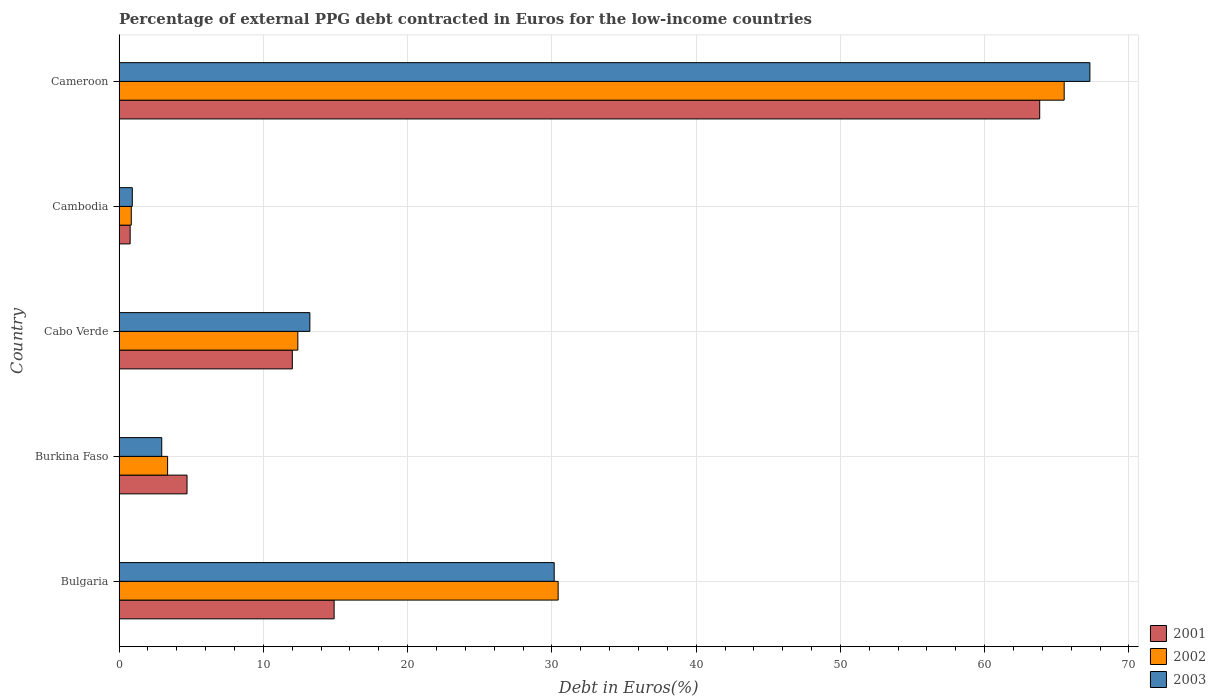Are the number of bars per tick equal to the number of legend labels?
Your answer should be compact. Yes. Are the number of bars on each tick of the Y-axis equal?
Your answer should be compact. Yes. How many bars are there on the 3rd tick from the top?
Make the answer very short. 3. How many bars are there on the 2nd tick from the bottom?
Provide a succinct answer. 3. What is the label of the 2nd group of bars from the top?
Offer a very short reply. Cambodia. What is the percentage of external PPG debt contracted in Euros in 2002 in Cabo Verde?
Offer a very short reply. 12.39. Across all countries, what is the maximum percentage of external PPG debt contracted in Euros in 2001?
Offer a terse response. 63.81. Across all countries, what is the minimum percentage of external PPG debt contracted in Euros in 2002?
Provide a short and direct response. 0.85. In which country was the percentage of external PPG debt contracted in Euros in 2002 maximum?
Your answer should be very brief. Cameroon. In which country was the percentage of external PPG debt contracted in Euros in 2001 minimum?
Your answer should be compact. Cambodia. What is the total percentage of external PPG debt contracted in Euros in 2003 in the graph?
Ensure brevity in your answer.  114.55. What is the difference between the percentage of external PPG debt contracted in Euros in 2001 in Bulgaria and that in Cabo Verde?
Your response must be concise. 2.9. What is the difference between the percentage of external PPG debt contracted in Euros in 2003 in Burkina Faso and the percentage of external PPG debt contracted in Euros in 2001 in Cabo Verde?
Your response must be concise. -9.05. What is the average percentage of external PPG debt contracted in Euros in 2002 per country?
Provide a succinct answer. 22.51. What is the difference between the percentage of external PPG debt contracted in Euros in 2002 and percentage of external PPG debt contracted in Euros in 2001 in Burkina Faso?
Ensure brevity in your answer.  -1.35. In how many countries, is the percentage of external PPG debt contracted in Euros in 2003 greater than 2 %?
Ensure brevity in your answer.  4. What is the ratio of the percentage of external PPG debt contracted in Euros in 2002 in Cabo Verde to that in Cameroon?
Make the answer very short. 0.19. Is the percentage of external PPG debt contracted in Euros in 2003 in Cabo Verde less than that in Cambodia?
Your answer should be compact. No. What is the difference between the highest and the second highest percentage of external PPG debt contracted in Euros in 2003?
Ensure brevity in your answer.  37.13. What is the difference between the highest and the lowest percentage of external PPG debt contracted in Euros in 2001?
Offer a terse response. 63.04. Is it the case that in every country, the sum of the percentage of external PPG debt contracted in Euros in 2002 and percentage of external PPG debt contracted in Euros in 2003 is greater than the percentage of external PPG debt contracted in Euros in 2001?
Make the answer very short. Yes. How many bars are there?
Offer a very short reply. 15. What is the difference between two consecutive major ticks on the X-axis?
Your answer should be very brief. 10. How many legend labels are there?
Give a very brief answer. 3. What is the title of the graph?
Your answer should be very brief. Percentage of external PPG debt contracted in Euros for the low-income countries. Does "1993" appear as one of the legend labels in the graph?
Offer a very short reply. No. What is the label or title of the X-axis?
Provide a short and direct response. Debt in Euros(%). What is the Debt in Euros(%) of 2001 in Bulgaria?
Provide a short and direct response. 14.91. What is the Debt in Euros(%) in 2002 in Bulgaria?
Your answer should be very brief. 30.44. What is the Debt in Euros(%) in 2003 in Bulgaria?
Make the answer very short. 30.16. What is the Debt in Euros(%) of 2001 in Burkina Faso?
Offer a very short reply. 4.71. What is the Debt in Euros(%) in 2002 in Burkina Faso?
Give a very brief answer. 3.37. What is the Debt in Euros(%) of 2003 in Burkina Faso?
Give a very brief answer. 2.96. What is the Debt in Euros(%) in 2001 in Cabo Verde?
Offer a very short reply. 12.01. What is the Debt in Euros(%) in 2002 in Cabo Verde?
Provide a short and direct response. 12.39. What is the Debt in Euros(%) of 2003 in Cabo Verde?
Offer a terse response. 13.22. What is the Debt in Euros(%) in 2001 in Cambodia?
Offer a terse response. 0.77. What is the Debt in Euros(%) of 2002 in Cambodia?
Offer a terse response. 0.85. What is the Debt in Euros(%) of 2003 in Cambodia?
Give a very brief answer. 0.92. What is the Debt in Euros(%) of 2001 in Cameroon?
Offer a terse response. 63.81. What is the Debt in Euros(%) in 2002 in Cameroon?
Make the answer very short. 65.51. What is the Debt in Euros(%) in 2003 in Cameroon?
Provide a succinct answer. 67.29. Across all countries, what is the maximum Debt in Euros(%) in 2001?
Your response must be concise. 63.81. Across all countries, what is the maximum Debt in Euros(%) of 2002?
Your response must be concise. 65.51. Across all countries, what is the maximum Debt in Euros(%) of 2003?
Your answer should be very brief. 67.29. Across all countries, what is the minimum Debt in Euros(%) in 2001?
Keep it short and to the point. 0.77. Across all countries, what is the minimum Debt in Euros(%) of 2002?
Make the answer very short. 0.85. Across all countries, what is the minimum Debt in Euros(%) of 2003?
Your response must be concise. 0.92. What is the total Debt in Euros(%) of 2001 in the graph?
Keep it short and to the point. 96.21. What is the total Debt in Euros(%) of 2002 in the graph?
Provide a succinct answer. 112.55. What is the total Debt in Euros(%) in 2003 in the graph?
Keep it short and to the point. 114.55. What is the difference between the Debt in Euros(%) of 2001 in Bulgaria and that in Burkina Faso?
Provide a short and direct response. 10.2. What is the difference between the Debt in Euros(%) of 2002 in Bulgaria and that in Burkina Faso?
Provide a short and direct response. 27.07. What is the difference between the Debt in Euros(%) of 2003 in Bulgaria and that in Burkina Faso?
Make the answer very short. 27.2. What is the difference between the Debt in Euros(%) in 2001 in Bulgaria and that in Cabo Verde?
Ensure brevity in your answer.  2.9. What is the difference between the Debt in Euros(%) in 2002 in Bulgaria and that in Cabo Verde?
Give a very brief answer. 18.04. What is the difference between the Debt in Euros(%) in 2003 in Bulgaria and that in Cabo Verde?
Provide a short and direct response. 16.94. What is the difference between the Debt in Euros(%) in 2001 in Bulgaria and that in Cambodia?
Provide a succinct answer. 14.14. What is the difference between the Debt in Euros(%) of 2002 in Bulgaria and that in Cambodia?
Provide a succinct answer. 29.59. What is the difference between the Debt in Euros(%) in 2003 in Bulgaria and that in Cambodia?
Make the answer very short. 29.24. What is the difference between the Debt in Euros(%) of 2001 in Bulgaria and that in Cameroon?
Make the answer very short. -48.91. What is the difference between the Debt in Euros(%) in 2002 in Bulgaria and that in Cameroon?
Provide a short and direct response. -35.07. What is the difference between the Debt in Euros(%) in 2003 in Bulgaria and that in Cameroon?
Keep it short and to the point. -37.13. What is the difference between the Debt in Euros(%) of 2001 in Burkina Faso and that in Cabo Verde?
Provide a succinct answer. -7.3. What is the difference between the Debt in Euros(%) of 2002 in Burkina Faso and that in Cabo Verde?
Give a very brief answer. -9.03. What is the difference between the Debt in Euros(%) in 2003 in Burkina Faso and that in Cabo Verde?
Your response must be concise. -10.27. What is the difference between the Debt in Euros(%) in 2001 in Burkina Faso and that in Cambodia?
Offer a very short reply. 3.94. What is the difference between the Debt in Euros(%) of 2002 in Burkina Faso and that in Cambodia?
Make the answer very short. 2.52. What is the difference between the Debt in Euros(%) in 2003 in Burkina Faso and that in Cambodia?
Your answer should be very brief. 2.04. What is the difference between the Debt in Euros(%) of 2001 in Burkina Faso and that in Cameroon?
Give a very brief answer. -59.1. What is the difference between the Debt in Euros(%) of 2002 in Burkina Faso and that in Cameroon?
Offer a very short reply. -62.14. What is the difference between the Debt in Euros(%) of 2003 in Burkina Faso and that in Cameroon?
Offer a very short reply. -64.33. What is the difference between the Debt in Euros(%) of 2001 in Cabo Verde and that in Cambodia?
Keep it short and to the point. 11.24. What is the difference between the Debt in Euros(%) of 2002 in Cabo Verde and that in Cambodia?
Your response must be concise. 11.55. What is the difference between the Debt in Euros(%) in 2003 in Cabo Verde and that in Cambodia?
Ensure brevity in your answer.  12.31. What is the difference between the Debt in Euros(%) of 2001 in Cabo Verde and that in Cameroon?
Your response must be concise. -51.8. What is the difference between the Debt in Euros(%) in 2002 in Cabo Verde and that in Cameroon?
Your answer should be very brief. -53.12. What is the difference between the Debt in Euros(%) in 2003 in Cabo Verde and that in Cameroon?
Provide a short and direct response. -54.07. What is the difference between the Debt in Euros(%) of 2001 in Cambodia and that in Cameroon?
Make the answer very short. -63.04. What is the difference between the Debt in Euros(%) in 2002 in Cambodia and that in Cameroon?
Your answer should be very brief. -64.66. What is the difference between the Debt in Euros(%) in 2003 in Cambodia and that in Cameroon?
Your answer should be very brief. -66.37. What is the difference between the Debt in Euros(%) in 2001 in Bulgaria and the Debt in Euros(%) in 2002 in Burkina Faso?
Provide a short and direct response. 11.54. What is the difference between the Debt in Euros(%) of 2001 in Bulgaria and the Debt in Euros(%) of 2003 in Burkina Faso?
Keep it short and to the point. 11.95. What is the difference between the Debt in Euros(%) of 2002 in Bulgaria and the Debt in Euros(%) of 2003 in Burkina Faso?
Your answer should be compact. 27.48. What is the difference between the Debt in Euros(%) in 2001 in Bulgaria and the Debt in Euros(%) in 2002 in Cabo Verde?
Ensure brevity in your answer.  2.51. What is the difference between the Debt in Euros(%) of 2001 in Bulgaria and the Debt in Euros(%) of 2003 in Cabo Verde?
Your answer should be very brief. 1.68. What is the difference between the Debt in Euros(%) in 2002 in Bulgaria and the Debt in Euros(%) in 2003 in Cabo Verde?
Give a very brief answer. 17.21. What is the difference between the Debt in Euros(%) in 2001 in Bulgaria and the Debt in Euros(%) in 2002 in Cambodia?
Your response must be concise. 14.06. What is the difference between the Debt in Euros(%) of 2001 in Bulgaria and the Debt in Euros(%) of 2003 in Cambodia?
Provide a short and direct response. 13.99. What is the difference between the Debt in Euros(%) in 2002 in Bulgaria and the Debt in Euros(%) in 2003 in Cambodia?
Your answer should be compact. 29.52. What is the difference between the Debt in Euros(%) of 2001 in Bulgaria and the Debt in Euros(%) of 2002 in Cameroon?
Provide a short and direct response. -50.6. What is the difference between the Debt in Euros(%) of 2001 in Bulgaria and the Debt in Euros(%) of 2003 in Cameroon?
Ensure brevity in your answer.  -52.38. What is the difference between the Debt in Euros(%) of 2002 in Bulgaria and the Debt in Euros(%) of 2003 in Cameroon?
Keep it short and to the point. -36.86. What is the difference between the Debt in Euros(%) in 2001 in Burkina Faso and the Debt in Euros(%) in 2002 in Cabo Verde?
Your answer should be very brief. -7.68. What is the difference between the Debt in Euros(%) in 2001 in Burkina Faso and the Debt in Euros(%) in 2003 in Cabo Verde?
Give a very brief answer. -8.51. What is the difference between the Debt in Euros(%) in 2002 in Burkina Faso and the Debt in Euros(%) in 2003 in Cabo Verde?
Ensure brevity in your answer.  -9.86. What is the difference between the Debt in Euros(%) of 2001 in Burkina Faso and the Debt in Euros(%) of 2002 in Cambodia?
Provide a short and direct response. 3.87. What is the difference between the Debt in Euros(%) in 2001 in Burkina Faso and the Debt in Euros(%) in 2003 in Cambodia?
Keep it short and to the point. 3.79. What is the difference between the Debt in Euros(%) in 2002 in Burkina Faso and the Debt in Euros(%) in 2003 in Cambodia?
Keep it short and to the point. 2.45. What is the difference between the Debt in Euros(%) of 2001 in Burkina Faso and the Debt in Euros(%) of 2002 in Cameroon?
Provide a succinct answer. -60.8. What is the difference between the Debt in Euros(%) in 2001 in Burkina Faso and the Debt in Euros(%) in 2003 in Cameroon?
Ensure brevity in your answer.  -62.58. What is the difference between the Debt in Euros(%) of 2002 in Burkina Faso and the Debt in Euros(%) of 2003 in Cameroon?
Your answer should be compact. -63.93. What is the difference between the Debt in Euros(%) in 2001 in Cabo Verde and the Debt in Euros(%) in 2002 in Cambodia?
Make the answer very short. 11.16. What is the difference between the Debt in Euros(%) of 2001 in Cabo Verde and the Debt in Euros(%) of 2003 in Cambodia?
Give a very brief answer. 11.09. What is the difference between the Debt in Euros(%) of 2002 in Cabo Verde and the Debt in Euros(%) of 2003 in Cambodia?
Provide a succinct answer. 11.47. What is the difference between the Debt in Euros(%) of 2001 in Cabo Verde and the Debt in Euros(%) of 2002 in Cameroon?
Your response must be concise. -53.5. What is the difference between the Debt in Euros(%) of 2001 in Cabo Verde and the Debt in Euros(%) of 2003 in Cameroon?
Give a very brief answer. -55.28. What is the difference between the Debt in Euros(%) of 2002 in Cabo Verde and the Debt in Euros(%) of 2003 in Cameroon?
Keep it short and to the point. -54.9. What is the difference between the Debt in Euros(%) of 2001 in Cambodia and the Debt in Euros(%) of 2002 in Cameroon?
Provide a succinct answer. -64.74. What is the difference between the Debt in Euros(%) in 2001 in Cambodia and the Debt in Euros(%) in 2003 in Cameroon?
Ensure brevity in your answer.  -66.52. What is the difference between the Debt in Euros(%) in 2002 in Cambodia and the Debt in Euros(%) in 2003 in Cameroon?
Your answer should be compact. -66.44. What is the average Debt in Euros(%) in 2001 per country?
Your answer should be very brief. 19.24. What is the average Debt in Euros(%) in 2002 per country?
Offer a very short reply. 22.51. What is the average Debt in Euros(%) of 2003 per country?
Ensure brevity in your answer.  22.91. What is the difference between the Debt in Euros(%) in 2001 and Debt in Euros(%) in 2002 in Bulgaria?
Your answer should be very brief. -15.53. What is the difference between the Debt in Euros(%) of 2001 and Debt in Euros(%) of 2003 in Bulgaria?
Ensure brevity in your answer.  -15.25. What is the difference between the Debt in Euros(%) of 2002 and Debt in Euros(%) of 2003 in Bulgaria?
Ensure brevity in your answer.  0.28. What is the difference between the Debt in Euros(%) of 2001 and Debt in Euros(%) of 2002 in Burkina Faso?
Make the answer very short. 1.35. What is the difference between the Debt in Euros(%) in 2001 and Debt in Euros(%) in 2003 in Burkina Faso?
Ensure brevity in your answer.  1.75. What is the difference between the Debt in Euros(%) of 2002 and Debt in Euros(%) of 2003 in Burkina Faso?
Offer a terse response. 0.41. What is the difference between the Debt in Euros(%) of 2001 and Debt in Euros(%) of 2002 in Cabo Verde?
Offer a very short reply. -0.38. What is the difference between the Debt in Euros(%) in 2001 and Debt in Euros(%) in 2003 in Cabo Verde?
Your answer should be very brief. -1.21. What is the difference between the Debt in Euros(%) in 2002 and Debt in Euros(%) in 2003 in Cabo Verde?
Your response must be concise. -0.83. What is the difference between the Debt in Euros(%) in 2001 and Debt in Euros(%) in 2002 in Cambodia?
Give a very brief answer. -0.08. What is the difference between the Debt in Euros(%) of 2001 and Debt in Euros(%) of 2003 in Cambodia?
Provide a succinct answer. -0.15. What is the difference between the Debt in Euros(%) in 2002 and Debt in Euros(%) in 2003 in Cambodia?
Offer a very short reply. -0.07. What is the difference between the Debt in Euros(%) in 2001 and Debt in Euros(%) in 2002 in Cameroon?
Offer a terse response. -1.7. What is the difference between the Debt in Euros(%) in 2001 and Debt in Euros(%) in 2003 in Cameroon?
Ensure brevity in your answer.  -3.48. What is the difference between the Debt in Euros(%) of 2002 and Debt in Euros(%) of 2003 in Cameroon?
Your answer should be very brief. -1.78. What is the ratio of the Debt in Euros(%) of 2001 in Bulgaria to that in Burkina Faso?
Keep it short and to the point. 3.16. What is the ratio of the Debt in Euros(%) of 2002 in Bulgaria to that in Burkina Faso?
Your response must be concise. 9.04. What is the ratio of the Debt in Euros(%) in 2003 in Bulgaria to that in Burkina Faso?
Keep it short and to the point. 10.19. What is the ratio of the Debt in Euros(%) of 2001 in Bulgaria to that in Cabo Verde?
Keep it short and to the point. 1.24. What is the ratio of the Debt in Euros(%) in 2002 in Bulgaria to that in Cabo Verde?
Your answer should be very brief. 2.46. What is the ratio of the Debt in Euros(%) in 2003 in Bulgaria to that in Cabo Verde?
Ensure brevity in your answer.  2.28. What is the ratio of the Debt in Euros(%) of 2001 in Bulgaria to that in Cambodia?
Offer a very short reply. 19.37. What is the ratio of the Debt in Euros(%) of 2002 in Bulgaria to that in Cambodia?
Ensure brevity in your answer.  35.95. What is the ratio of the Debt in Euros(%) in 2003 in Bulgaria to that in Cambodia?
Make the answer very short. 32.85. What is the ratio of the Debt in Euros(%) of 2001 in Bulgaria to that in Cameroon?
Offer a terse response. 0.23. What is the ratio of the Debt in Euros(%) of 2002 in Bulgaria to that in Cameroon?
Provide a succinct answer. 0.46. What is the ratio of the Debt in Euros(%) of 2003 in Bulgaria to that in Cameroon?
Provide a succinct answer. 0.45. What is the ratio of the Debt in Euros(%) of 2001 in Burkina Faso to that in Cabo Verde?
Your answer should be compact. 0.39. What is the ratio of the Debt in Euros(%) in 2002 in Burkina Faso to that in Cabo Verde?
Your answer should be compact. 0.27. What is the ratio of the Debt in Euros(%) of 2003 in Burkina Faso to that in Cabo Verde?
Your response must be concise. 0.22. What is the ratio of the Debt in Euros(%) of 2001 in Burkina Faso to that in Cambodia?
Your answer should be very brief. 6.12. What is the ratio of the Debt in Euros(%) of 2002 in Burkina Faso to that in Cambodia?
Provide a short and direct response. 3.98. What is the ratio of the Debt in Euros(%) in 2003 in Burkina Faso to that in Cambodia?
Your answer should be very brief. 3.22. What is the ratio of the Debt in Euros(%) of 2001 in Burkina Faso to that in Cameroon?
Your answer should be compact. 0.07. What is the ratio of the Debt in Euros(%) of 2002 in Burkina Faso to that in Cameroon?
Offer a terse response. 0.05. What is the ratio of the Debt in Euros(%) of 2003 in Burkina Faso to that in Cameroon?
Offer a terse response. 0.04. What is the ratio of the Debt in Euros(%) in 2001 in Cabo Verde to that in Cambodia?
Your response must be concise. 15.6. What is the ratio of the Debt in Euros(%) of 2002 in Cabo Verde to that in Cambodia?
Provide a succinct answer. 14.64. What is the ratio of the Debt in Euros(%) in 2003 in Cabo Verde to that in Cambodia?
Keep it short and to the point. 14.41. What is the ratio of the Debt in Euros(%) in 2001 in Cabo Verde to that in Cameroon?
Your answer should be very brief. 0.19. What is the ratio of the Debt in Euros(%) of 2002 in Cabo Verde to that in Cameroon?
Ensure brevity in your answer.  0.19. What is the ratio of the Debt in Euros(%) of 2003 in Cabo Verde to that in Cameroon?
Give a very brief answer. 0.2. What is the ratio of the Debt in Euros(%) in 2001 in Cambodia to that in Cameroon?
Provide a succinct answer. 0.01. What is the ratio of the Debt in Euros(%) of 2002 in Cambodia to that in Cameroon?
Provide a succinct answer. 0.01. What is the ratio of the Debt in Euros(%) in 2003 in Cambodia to that in Cameroon?
Keep it short and to the point. 0.01. What is the difference between the highest and the second highest Debt in Euros(%) in 2001?
Give a very brief answer. 48.91. What is the difference between the highest and the second highest Debt in Euros(%) in 2002?
Provide a short and direct response. 35.07. What is the difference between the highest and the second highest Debt in Euros(%) of 2003?
Offer a terse response. 37.13. What is the difference between the highest and the lowest Debt in Euros(%) in 2001?
Your answer should be very brief. 63.04. What is the difference between the highest and the lowest Debt in Euros(%) of 2002?
Give a very brief answer. 64.66. What is the difference between the highest and the lowest Debt in Euros(%) in 2003?
Your response must be concise. 66.37. 